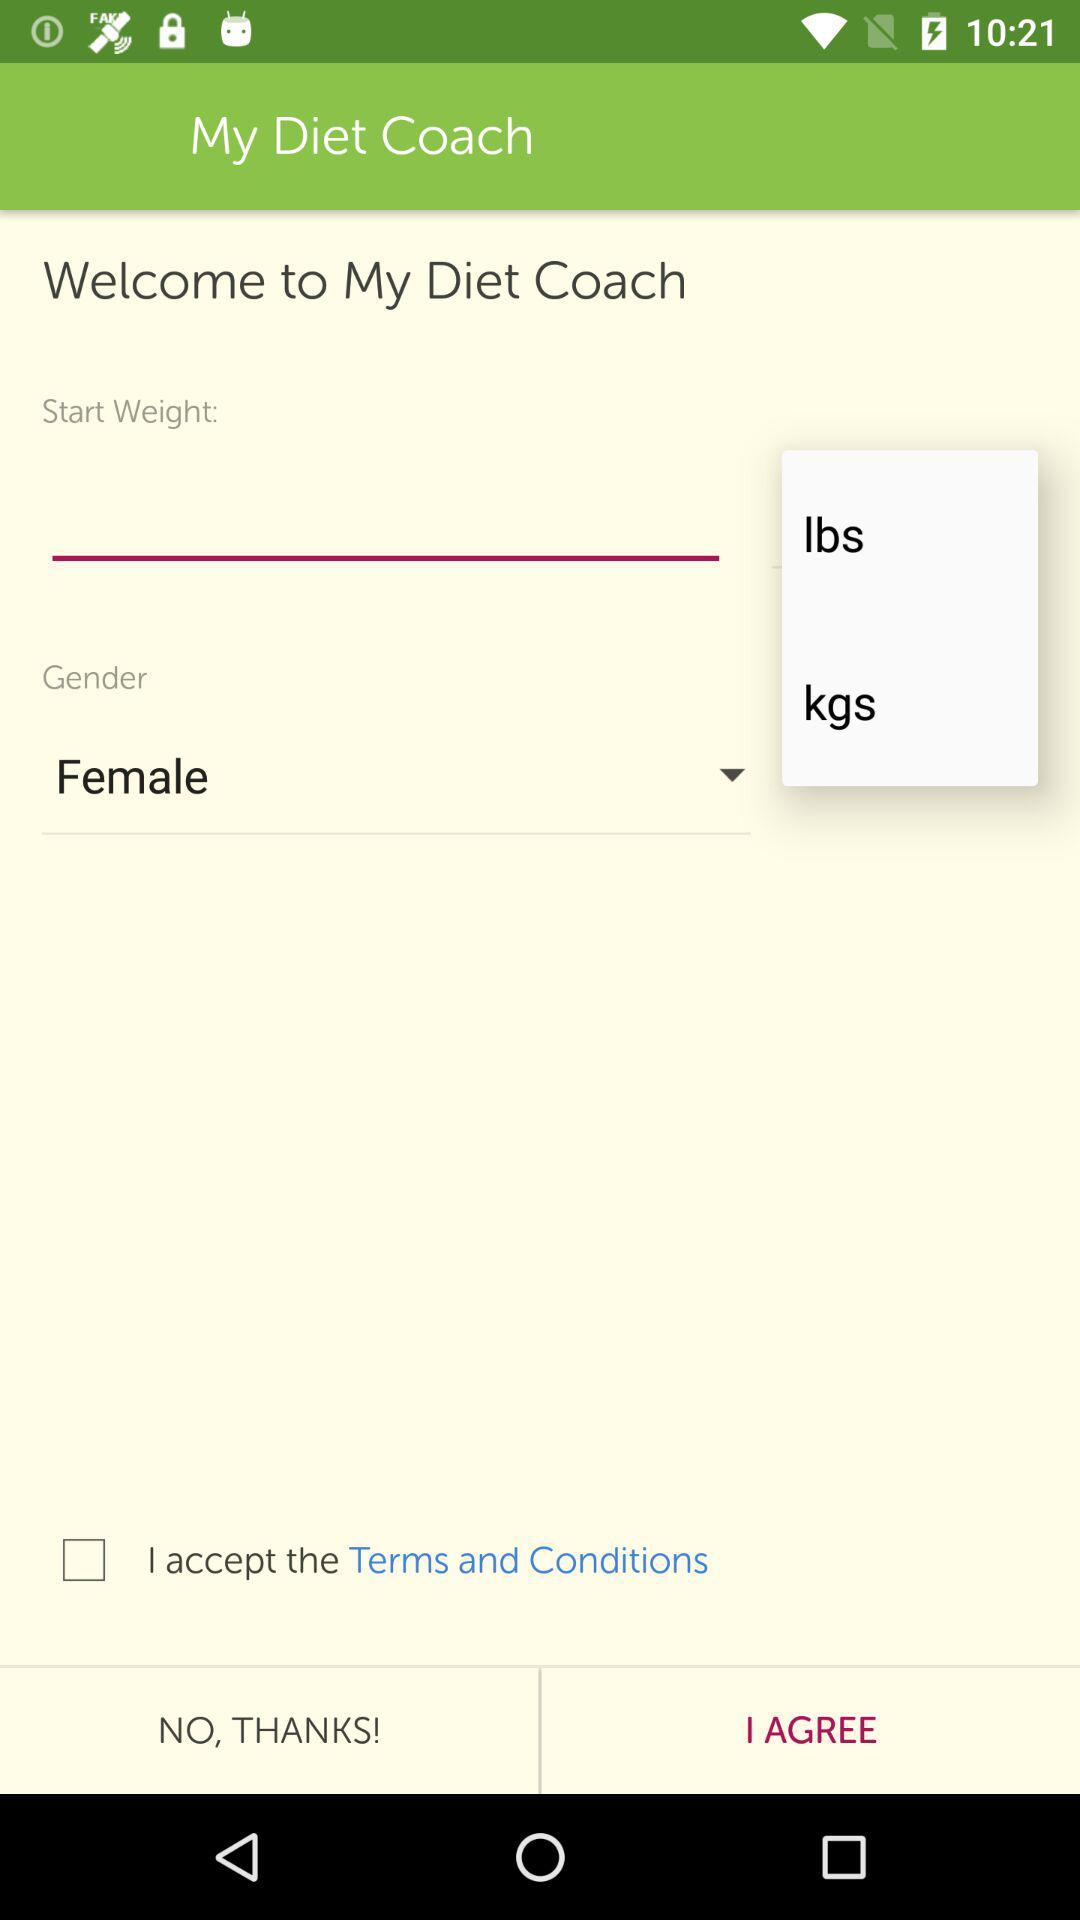What are the measurement options for the weight? The measurement options are lbs and kgs. 